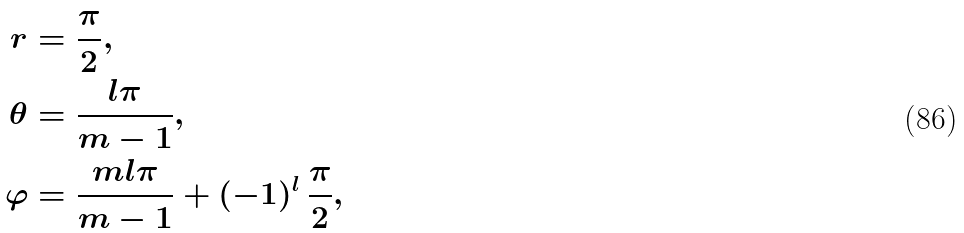<formula> <loc_0><loc_0><loc_500><loc_500>r & = \frac { \pi } { 2 } , \\ \theta & = \frac { l \pi } { m - 1 } , \\ \varphi & = \frac { m l \pi } { m - 1 } + ( - 1 ) ^ { l } \, \frac { \pi } { 2 } ,</formula> 